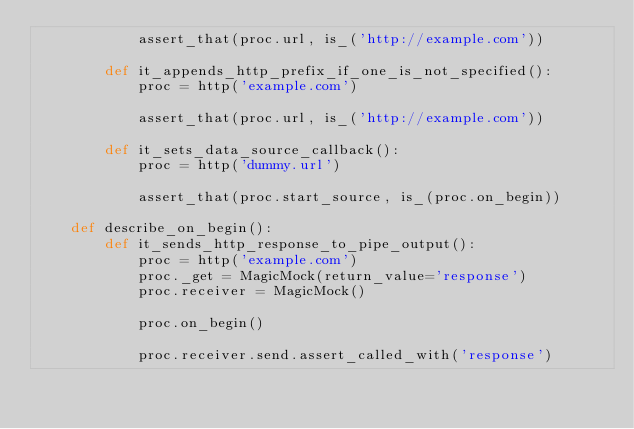Convert code to text. <code><loc_0><loc_0><loc_500><loc_500><_Python_>            assert_that(proc.url, is_('http://example.com'))

        def it_appends_http_prefix_if_one_is_not_specified():
            proc = http('example.com')

            assert_that(proc.url, is_('http://example.com'))

        def it_sets_data_source_callback():
            proc = http('dummy.url')

            assert_that(proc.start_source, is_(proc.on_begin))

    def describe_on_begin():
        def it_sends_http_response_to_pipe_output():
            proc = http('example.com')
            proc._get = MagicMock(return_value='response')
            proc.receiver = MagicMock()

            proc.on_begin()

            proc.receiver.send.assert_called_with('response')
</code> 